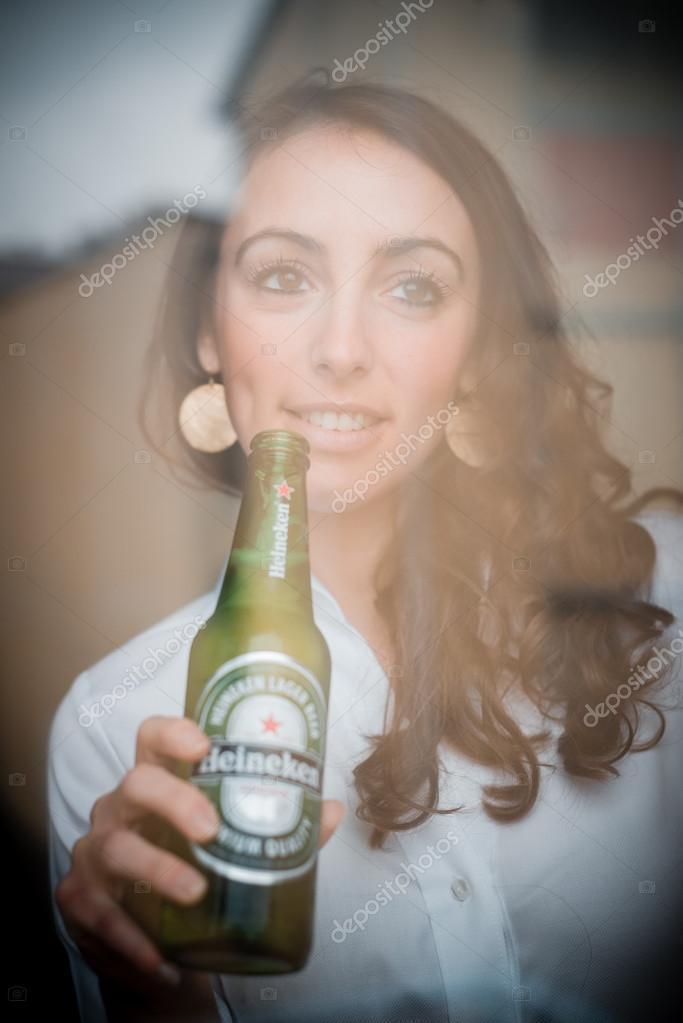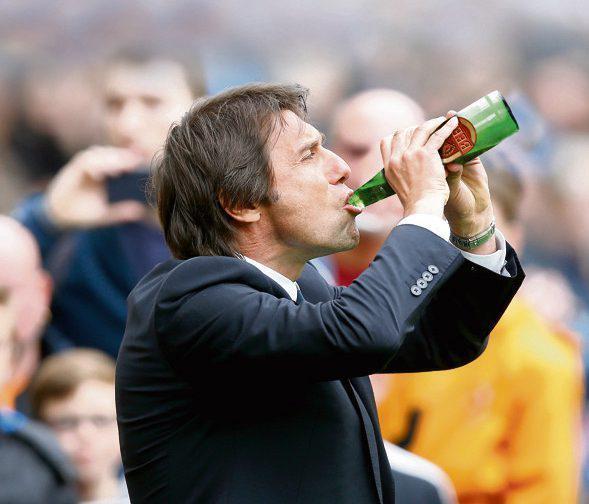The first image is the image on the left, the second image is the image on the right. Assess this claim about the two images: "Three hands are touching three bottles.". Correct or not? Answer yes or no. No. The first image is the image on the left, the second image is the image on the right. Evaluate the accuracy of this statement regarding the images: "An adult is drinking a beer with the bottle touching their mouth.". Is it true? Answer yes or no. Yes. 